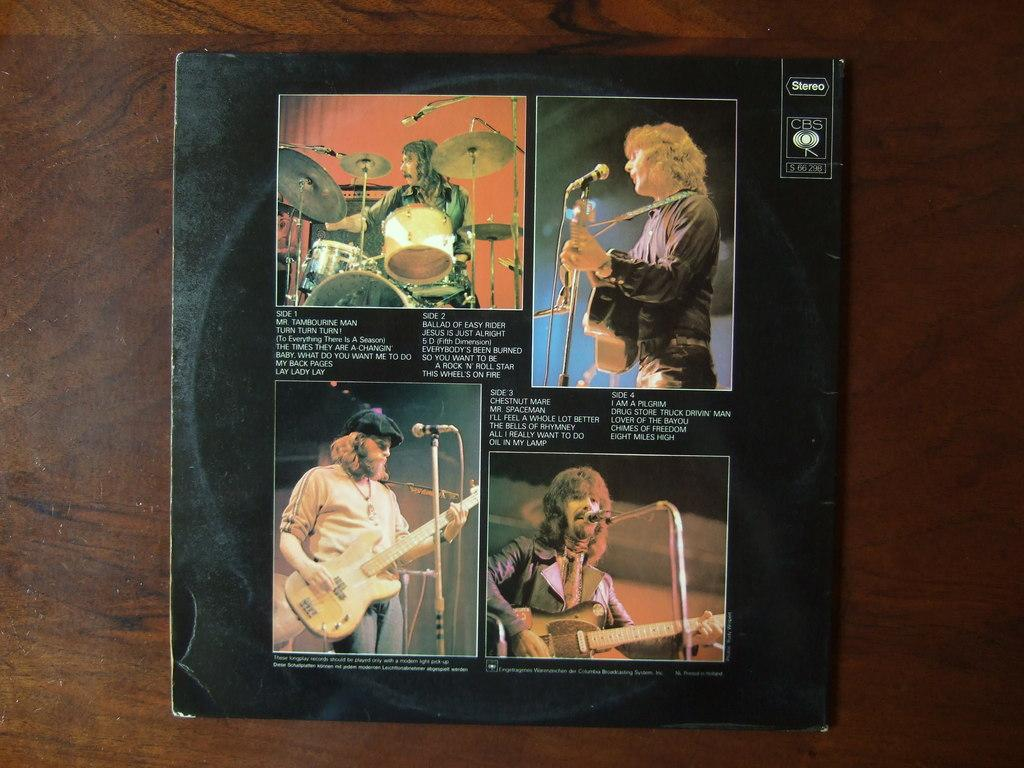<image>
Render a clear and concise summary of the photo. A record cover has song lists from four different sides. 